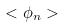Convert formula to latex. <formula><loc_0><loc_0><loc_500><loc_500>< \phi _ { n } ></formula> 